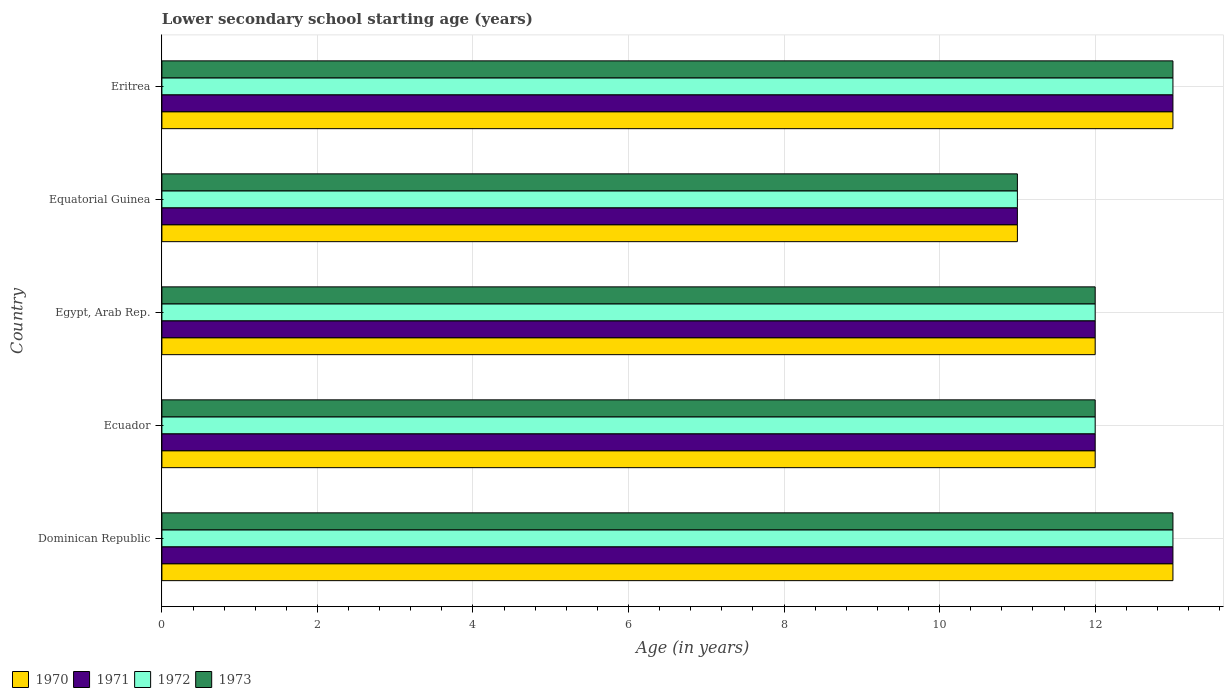How many groups of bars are there?
Ensure brevity in your answer.  5. Are the number of bars on each tick of the Y-axis equal?
Give a very brief answer. Yes. How many bars are there on the 4th tick from the top?
Ensure brevity in your answer.  4. How many bars are there on the 2nd tick from the bottom?
Offer a very short reply. 4. What is the label of the 3rd group of bars from the top?
Offer a very short reply. Egypt, Arab Rep. In how many cases, is the number of bars for a given country not equal to the number of legend labels?
Keep it short and to the point. 0. In which country was the lower secondary school starting age of children in 1972 maximum?
Your response must be concise. Dominican Republic. In which country was the lower secondary school starting age of children in 1971 minimum?
Ensure brevity in your answer.  Equatorial Guinea. What is the difference between the lower secondary school starting age of children in 1973 in Dominican Republic and that in Equatorial Guinea?
Make the answer very short. 2. What is the difference between the lower secondary school starting age of children in 1971 in Eritrea and the lower secondary school starting age of children in 1970 in Dominican Republic?
Your answer should be compact. 0. What is the average lower secondary school starting age of children in 1972 per country?
Your response must be concise. 12.2. What is the ratio of the lower secondary school starting age of children in 1971 in Dominican Republic to that in Equatorial Guinea?
Make the answer very short. 1.18. Is the lower secondary school starting age of children in 1971 in Equatorial Guinea less than that in Eritrea?
Provide a succinct answer. Yes. In how many countries, is the lower secondary school starting age of children in 1971 greater than the average lower secondary school starting age of children in 1971 taken over all countries?
Provide a short and direct response. 2. Is it the case that in every country, the sum of the lower secondary school starting age of children in 1970 and lower secondary school starting age of children in 1971 is greater than the sum of lower secondary school starting age of children in 1972 and lower secondary school starting age of children in 1973?
Keep it short and to the point. No. What does the 1st bar from the top in Equatorial Guinea represents?
Keep it short and to the point. 1973. What does the 2nd bar from the bottom in Ecuador represents?
Make the answer very short. 1971. Is it the case that in every country, the sum of the lower secondary school starting age of children in 1973 and lower secondary school starting age of children in 1972 is greater than the lower secondary school starting age of children in 1971?
Give a very brief answer. Yes. How many bars are there?
Your answer should be compact. 20. How many countries are there in the graph?
Keep it short and to the point. 5. What is the difference between two consecutive major ticks on the X-axis?
Provide a succinct answer. 2. Does the graph contain any zero values?
Offer a very short reply. No. How many legend labels are there?
Your answer should be very brief. 4. How are the legend labels stacked?
Your answer should be very brief. Horizontal. What is the title of the graph?
Offer a very short reply. Lower secondary school starting age (years). What is the label or title of the X-axis?
Give a very brief answer. Age (in years). What is the label or title of the Y-axis?
Give a very brief answer. Country. What is the Age (in years) of 1971 in Dominican Republic?
Ensure brevity in your answer.  13. What is the Age (in years) of 1972 in Dominican Republic?
Give a very brief answer. 13. What is the Age (in years) of 1973 in Dominican Republic?
Give a very brief answer. 13. What is the Age (in years) in 1970 in Ecuador?
Offer a terse response. 12. What is the Age (in years) in 1971 in Egypt, Arab Rep.?
Your answer should be very brief. 12. What is the Age (in years) in 1972 in Equatorial Guinea?
Your response must be concise. 11. What is the Age (in years) of 1971 in Eritrea?
Ensure brevity in your answer.  13. Across all countries, what is the maximum Age (in years) of 1970?
Ensure brevity in your answer.  13. Across all countries, what is the maximum Age (in years) in 1971?
Offer a terse response. 13. Across all countries, what is the maximum Age (in years) in 1972?
Offer a terse response. 13. Across all countries, what is the minimum Age (in years) in 1970?
Keep it short and to the point. 11. Across all countries, what is the minimum Age (in years) of 1972?
Ensure brevity in your answer.  11. What is the total Age (in years) of 1970 in the graph?
Give a very brief answer. 61. What is the total Age (in years) in 1971 in the graph?
Provide a succinct answer. 61. What is the total Age (in years) in 1972 in the graph?
Your answer should be compact. 61. What is the difference between the Age (in years) of 1971 in Dominican Republic and that in Ecuador?
Provide a succinct answer. 1. What is the difference between the Age (in years) of 1971 in Dominican Republic and that in Egypt, Arab Rep.?
Ensure brevity in your answer.  1. What is the difference between the Age (in years) in 1972 in Dominican Republic and that in Egypt, Arab Rep.?
Ensure brevity in your answer.  1. What is the difference between the Age (in years) of 1971 in Dominican Republic and that in Equatorial Guinea?
Keep it short and to the point. 2. What is the difference between the Age (in years) of 1972 in Dominican Republic and that in Equatorial Guinea?
Make the answer very short. 2. What is the difference between the Age (in years) of 1973 in Dominican Republic and that in Equatorial Guinea?
Keep it short and to the point. 2. What is the difference between the Age (in years) in 1972 in Dominican Republic and that in Eritrea?
Your answer should be compact. 0. What is the difference between the Age (in years) in 1970 in Ecuador and that in Egypt, Arab Rep.?
Give a very brief answer. 0. What is the difference between the Age (in years) in 1972 in Ecuador and that in Egypt, Arab Rep.?
Provide a succinct answer. 0. What is the difference between the Age (in years) in 1973 in Ecuador and that in Egypt, Arab Rep.?
Make the answer very short. 0. What is the difference between the Age (in years) of 1970 in Ecuador and that in Equatorial Guinea?
Ensure brevity in your answer.  1. What is the difference between the Age (in years) in 1971 in Ecuador and that in Equatorial Guinea?
Give a very brief answer. 1. What is the difference between the Age (in years) of 1972 in Ecuador and that in Equatorial Guinea?
Provide a short and direct response. 1. What is the difference between the Age (in years) of 1973 in Ecuador and that in Equatorial Guinea?
Provide a short and direct response. 1. What is the difference between the Age (in years) of 1970 in Ecuador and that in Eritrea?
Your answer should be very brief. -1. What is the difference between the Age (in years) of 1971 in Ecuador and that in Eritrea?
Offer a very short reply. -1. What is the difference between the Age (in years) in 1973 in Ecuador and that in Eritrea?
Provide a short and direct response. -1. What is the difference between the Age (in years) in 1970 in Egypt, Arab Rep. and that in Equatorial Guinea?
Your answer should be compact. 1. What is the difference between the Age (in years) of 1971 in Egypt, Arab Rep. and that in Equatorial Guinea?
Give a very brief answer. 1. What is the difference between the Age (in years) of 1972 in Egypt, Arab Rep. and that in Equatorial Guinea?
Give a very brief answer. 1. What is the difference between the Age (in years) of 1973 in Egypt, Arab Rep. and that in Equatorial Guinea?
Give a very brief answer. 1. What is the difference between the Age (in years) in 1970 in Egypt, Arab Rep. and that in Eritrea?
Keep it short and to the point. -1. What is the difference between the Age (in years) of 1972 in Egypt, Arab Rep. and that in Eritrea?
Ensure brevity in your answer.  -1. What is the difference between the Age (in years) of 1971 in Equatorial Guinea and that in Eritrea?
Give a very brief answer. -2. What is the difference between the Age (in years) in 1972 in Equatorial Guinea and that in Eritrea?
Your answer should be very brief. -2. What is the difference between the Age (in years) in 1973 in Equatorial Guinea and that in Eritrea?
Offer a very short reply. -2. What is the difference between the Age (in years) in 1970 in Dominican Republic and the Age (in years) in 1972 in Ecuador?
Offer a very short reply. 1. What is the difference between the Age (in years) of 1970 in Dominican Republic and the Age (in years) of 1973 in Ecuador?
Give a very brief answer. 1. What is the difference between the Age (in years) in 1970 in Dominican Republic and the Age (in years) in 1972 in Egypt, Arab Rep.?
Your answer should be compact. 1. What is the difference between the Age (in years) in 1970 in Dominican Republic and the Age (in years) in 1973 in Egypt, Arab Rep.?
Provide a short and direct response. 1. What is the difference between the Age (in years) of 1971 in Dominican Republic and the Age (in years) of 1972 in Egypt, Arab Rep.?
Your answer should be compact. 1. What is the difference between the Age (in years) of 1970 in Dominican Republic and the Age (in years) of 1971 in Equatorial Guinea?
Keep it short and to the point. 2. What is the difference between the Age (in years) in 1970 in Dominican Republic and the Age (in years) in 1972 in Equatorial Guinea?
Make the answer very short. 2. What is the difference between the Age (in years) of 1970 in Dominican Republic and the Age (in years) of 1973 in Equatorial Guinea?
Offer a very short reply. 2. What is the difference between the Age (in years) in 1972 in Dominican Republic and the Age (in years) in 1973 in Equatorial Guinea?
Keep it short and to the point. 2. What is the difference between the Age (in years) in 1970 in Dominican Republic and the Age (in years) in 1972 in Eritrea?
Offer a terse response. 0. What is the difference between the Age (in years) of 1971 in Dominican Republic and the Age (in years) of 1972 in Eritrea?
Give a very brief answer. 0. What is the difference between the Age (in years) of 1971 in Dominican Republic and the Age (in years) of 1973 in Eritrea?
Make the answer very short. 0. What is the difference between the Age (in years) of 1972 in Dominican Republic and the Age (in years) of 1973 in Eritrea?
Ensure brevity in your answer.  0. What is the difference between the Age (in years) of 1970 in Ecuador and the Age (in years) of 1971 in Egypt, Arab Rep.?
Make the answer very short. 0. What is the difference between the Age (in years) of 1970 in Ecuador and the Age (in years) of 1972 in Egypt, Arab Rep.?
Offer a terse response. 0. What is the difference between the Age (in years) in 1970 in Ecuador and the Age (in years) in 1973 in Egypt, Arab Rep.?
Give a very brief answer. 0. What is the difference between the Age (in years) in 1971 in Ecuador and the Age (in years) in 1973 in Egypt, Arab Rep.?
Provide a short and direct response. 0. What is the difference between the Age (in years) in 1970 in Ecuador and the Age (in years) in 1971 in Equatorial Guinea?
Provide a short and direct response. 1. What is the difference between the Age (in years) in 1970 in Ecuador and the Age (in years) in 1972 in Equatorial Guinea?
Offer a terse response. 1. What is the difference between the Age (in years) of 1970 in Ecuador and the Age (in years) of 1973 in Equatorial Guinea?
Make the answer very short. 1. What is the difference between the Age (in years) of 1971 in Ecuador and the Age (in years) of 1972 in Equatorial Guinea?
Provide a short and direct response. 1. What is the difference between the Age (in years) in 1970 in Ecuador and the Age (in years) in 1972 in Eritrea?
Keep it short and to the point. -1. What is the difference between the Age (in years) in 1971 in Ecuador and the Age (in years) in 1973 in Eritrea?
Your answer should be very brief. -1. What is the difference between the Age (in years) in 1972 in Ecuador and the Age (in years) in 1973 in Eritrea?
Give a very brief answer. -1. What is the difference between the Age (in years) of 1970 in Egypt, Arab Rep. and the Age (in years) of 1972 in Equatorial Guinea?
Provide a short and direct response. 1. What is the difference between the Age (in years) of 1972 in Egypt, Arab Rep. and the Age (in years) of 1973 in Equatorial Guinea?
Offer a terse response. 1. What is the difference between the Age (in years) of 1970 in Egypt, Arab Rep. and the Age (in years) of 1973 in Eritrea?
Keep it short and to the point. -1. What is the difference between the Age (in years) in 1971 in Egypt, Arab Rep. and the Age (in years) in 1972 in Eritrea?
Your answer should be very brief. -1. What is the difference between the Age (in years) of 1970 in Equatorial Guinea and the Age (in years) of 1972 in Eritrea?
Offer a terse response. -2. What is the difference between the Age (in years) in 1971 in Equatorial Guinea and the Age (in years) in 1972 in Eritrea?
Provide a succinct answer. -2. What is the difference between the Age (in years) of 1971 in Equatorial Guinea and the Age (in years) of 1973 in Eritrea?
Give a very brief answer. -2. What is the average Age (in years) in 1971 per country?
Provide a short and direct response. 12.2. What is the average Age (in years) in 1973 per country?
Give a very brief answer. 12.2. What is the difference between the Age (in years) in 1970 and Age (in years) in 1971 in Dominican Republic?
Offer a terse response. 0. What is the difference between the Age (in years) of 1971 and Age (in years) of 1973 in Dominican Republic?
Provide a short and direct response. 0. What is the difference between the Age (in years) in 1970 and Age (in years) in 1972 in Ecuador?
Your answer should be compact. 0. What is the difference between the Age (in years) in 1971 and Age (in years) in 1972 in Ecuador?
Make the answer very short. 0. What is the difference between the Age (in years) in 1972 and Age (in years) in 1973 in Ecuador?
Provide a short and direct response. 0. What is the difference between the Age (in years) in 1970 and Age (in years) in 1972 in Egypt, Arab Rep.?
Make the answer very short. 0. What is the difference between the Age (in years) of 1971 and Age (in years) of 1973 in Egypt, Arab Rep.?
Make the answer very short. 0. What is the difference between the Age (in years) in 1970 and Age (in years) in 1971 in Equatorial Guinea?
Provide a succinct answer. 0. What is the difference between the Age (in years) in 1971 and Age (in years) in 1972 in Equatorial Guinea?
Your answer should be very brief. 0. What is the difference between the Age (in years) of 1972 and Age (in years) of 1973 in Equatorial Guinea?
Give a very brief answer. 0. What is the difference between the Age (in years) in 1970 and Age (in years) in 1972 in Eritrea?
Provide a short and direct response. 0. What is the difference between the Age (in years) in 1970 and Age (in years) in 1973 in Eritrea?
Keep it short and to the point. 0. What is the difference between the Age (in years) in 1971 and Age (in years) in 1973 in Eritrea?
Your answer should be compact. 0. What is the difference between the Age (in years) of 1972 and Age (in years) of 1973 in Eritrea?
Offer a terse response. 0. What is the ratio of the Age (in years) of 1970 in Dominican Republic to that in Ecuador?
Keep it short and to the point. 1.08. What is the ratio of the Age (in years) of 1971 in Dominican Republic to that in Ecuador?
Make the answer very short. 1.08. What is the ratio of the Age (in years) in 1973 in Dominican Republic to that in Ecuador?
Provide a short and direct response. 1.08. What is the ratio of the Age (in years) in 1970 in Dominican Republic to that in Egypt, Arab Rep.?
Offer a terse response. 1.08. What is the ratio of the Age (in years) in 1972 in Dominican Republic to that in Egypt, Arab Rep.?
Ensure brevity in your answer.  1.08. What is the ratio of the Age (in years) of 1973 in Dominican Republic to that in Egypt, Arab Rep.?
Make the answer very short. 1.08. What is the ratio of the Age (in years) in 1970 in Dominican Republic to that in Equatorial Guinea?
Keep it short and to the point. 1.18. What is the ratio of the Age (in years) in 1971 in Dominican Republic to that in Equatorial Guinea?
Keep it short and to the point. 1.18. What is the ratio of the Age (in years) of 1972 in Dominican Republic to that in Equatorial Guinea?
Offer a very short reply. 1.18. What is the ratio of the Age (in years) of 1973 in Dominican Republic to that in Equatorial Guinea?
Ensure brevity in your answer.  1.18. What is the ratio of the Age (in years) in 1970 in Dominican Republic to that in Eritrea?
Provide a short and direct response. 1. What is the ratio of the Age (in years) of 1971 in Dominican Republic to that in Eritrea?
Give a very brief answer. 1. What is the ratio of the Age (in years) in 1972 in Dominican Republic to that in Eritrea?
Offer a terse response. 1. What is the ratio of the Age (in years) in 1971 in Ecuador to that in Egypt, Arab Rep.?
Give a very brief answer. 1. What is the ratio of the Age (in years) of 1972 in Ecuador to that in Egypt, Arab Rep.?
Keep it short and to the point. 1. What is the ratio of the Age (in years) in 1973 in Ecuador to that in Egypt, Arab Rep.?
Provide a succinct answer. 1. What is the ratio of the Age (in years) of 1970 in Ecuador to that in Eritrea?
Keep it short and to the point. 0.92. What is the ratio of the Age (in years) of 1971 in Ecuador to that in Eritrea?
Ensure brevity in your answer.  0.92. What is the ratio of the Age (in years) in 1972 in Ecuador to that in Eritrea?
Your answer should be very brief. 0.92. What is the ratio of the Age (in years) in 1970 in Egypt, Arab Rep. to that in Equatorial Guinea?
Provide a succinct answer. 1.09. What is the ratio of the Age (in years) of 1970 in Equatorial Guinea to that in Eritrea?
Your answer should be compact. 0.85. What is the ratio of the Age (in years) in 1971 in Equatorial Guinea to that in Eritrea?
Keep it short and to the point. 0.85. What is the ratio of the Age (in years) of 1972 in Equatorial Guinea to that in Eritrea?
Ensure brevity in your answer.  0.85. What is the ratio of the Age (in years) of 1973 in Equatorial Guinea to that in Eritrea?
Provide a short and direct response. 0.85. What is the difference between the highest and the second highest Age (in years) of 1972?
Your answer should be very brief. 0. What is the difference between the highest and the lowest Age (in years) of 1970?
Keep it short and to the point. 2. What is the difference between the highest and the lowest Age (in years) in 1971?
Your response must be concise. 2. What is the difference between the highest and the lowest Age (in years) in 1973?
Make the answer very short. 2. 